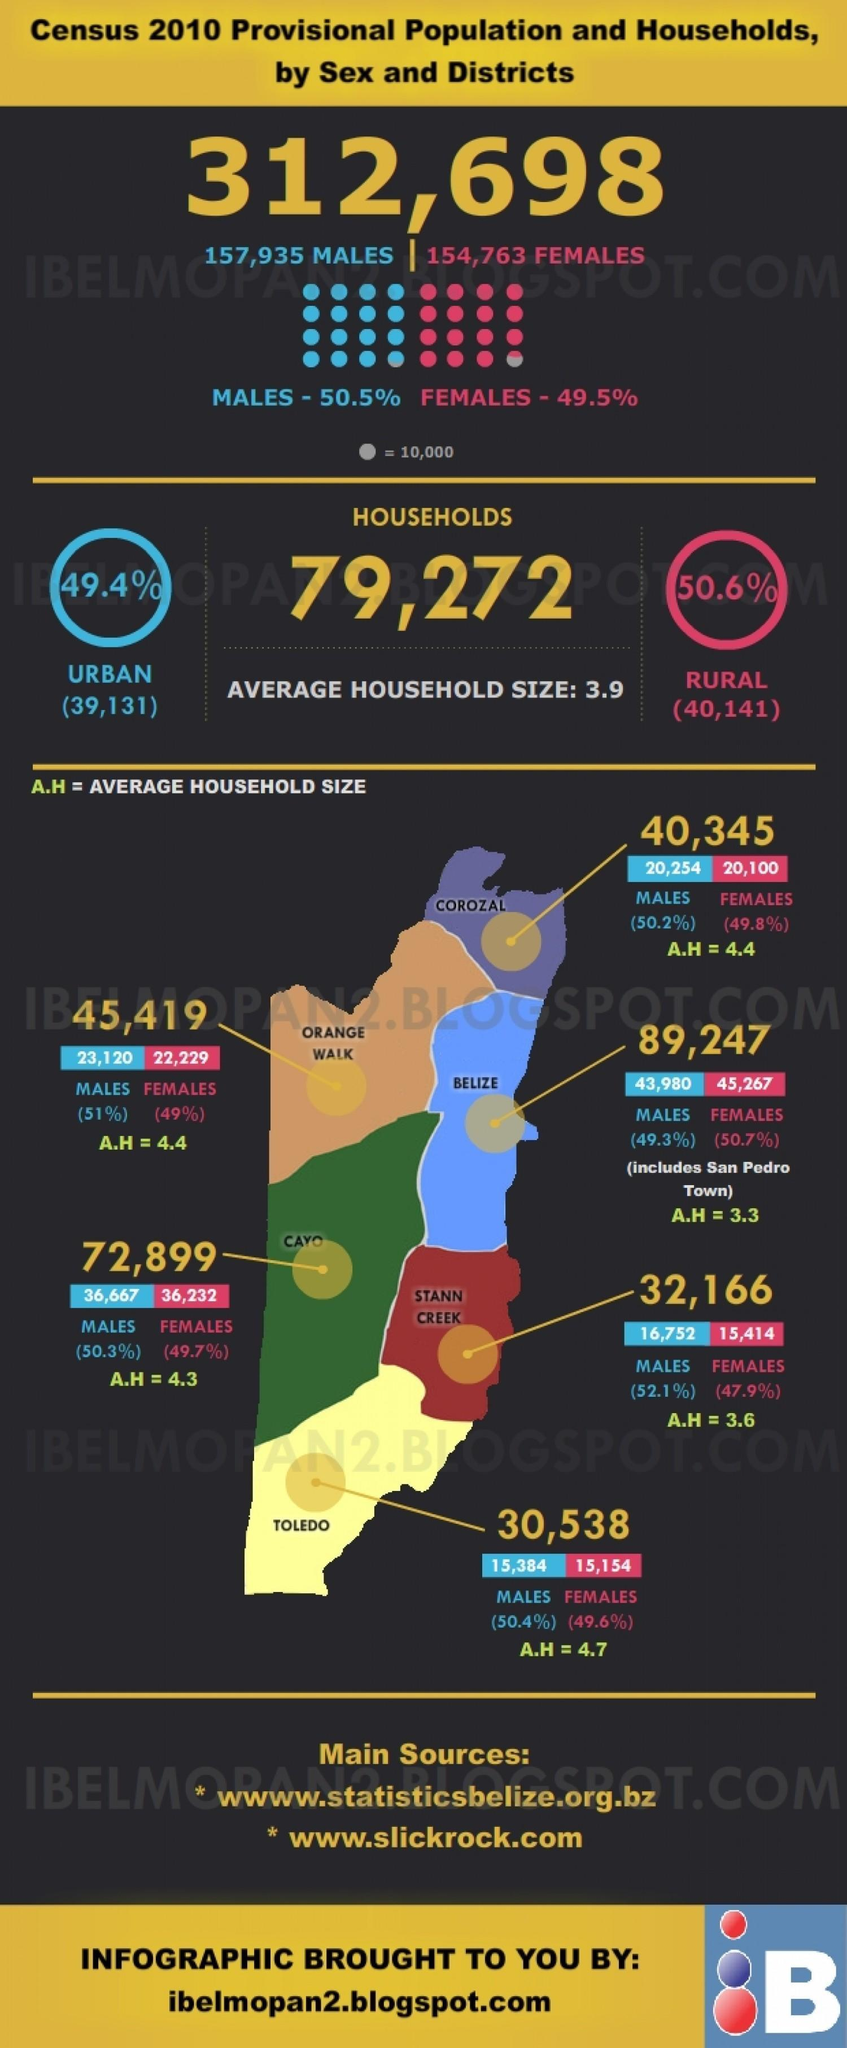How many districts have an average household size of 4.4?
Answer the question with a short phrase. 2 How many districts have an average household size greater than 4? 4 How many districts have an average household size smaller than 4? 2 In which district, the male population is the highest? Belize 